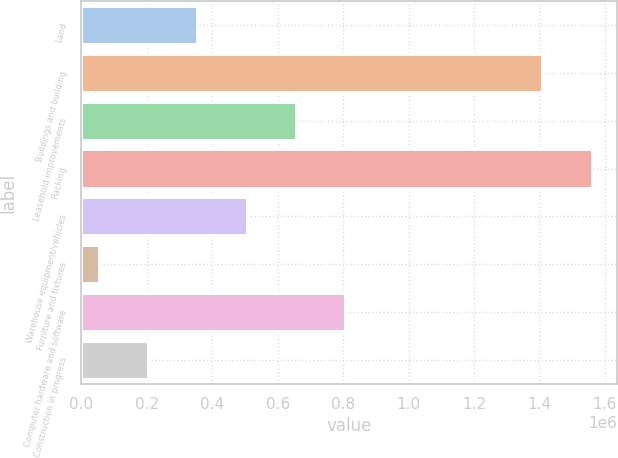Convert chart. <chart><loc_0><loc_0><loc_500><loc_500><bar_chart><fcel>Land<fcel>Buildings and building<fcel>Leasehold improvements<fcel>Racking<fcel>Warehouse equipment/vehicles<fcel>Furniture and fixtures<fcel>Computer hardware and software<fcel>Construction in progress<nl><fcel>354428<fcel>1.40933e+06<fcel>655667<fcel>1.55995e+06<fcel>505047<fcel>53189<fcel>806286<fcel>203808<nl></chart> 